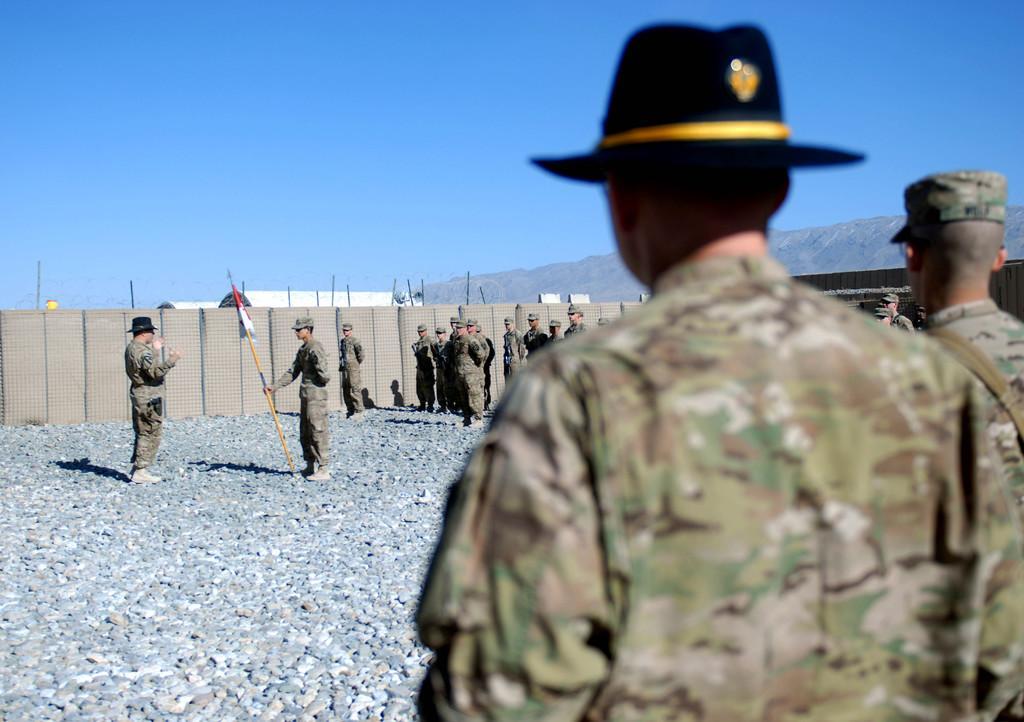Please provide a concise description of this image. In this image in the foreground there are two persons one person is wearing a hat, and in the background there are group of people one person is holding a pole and flag and some boards poles, buildings, mountains. At the bottom there are some stones, and at the top there is sky. 